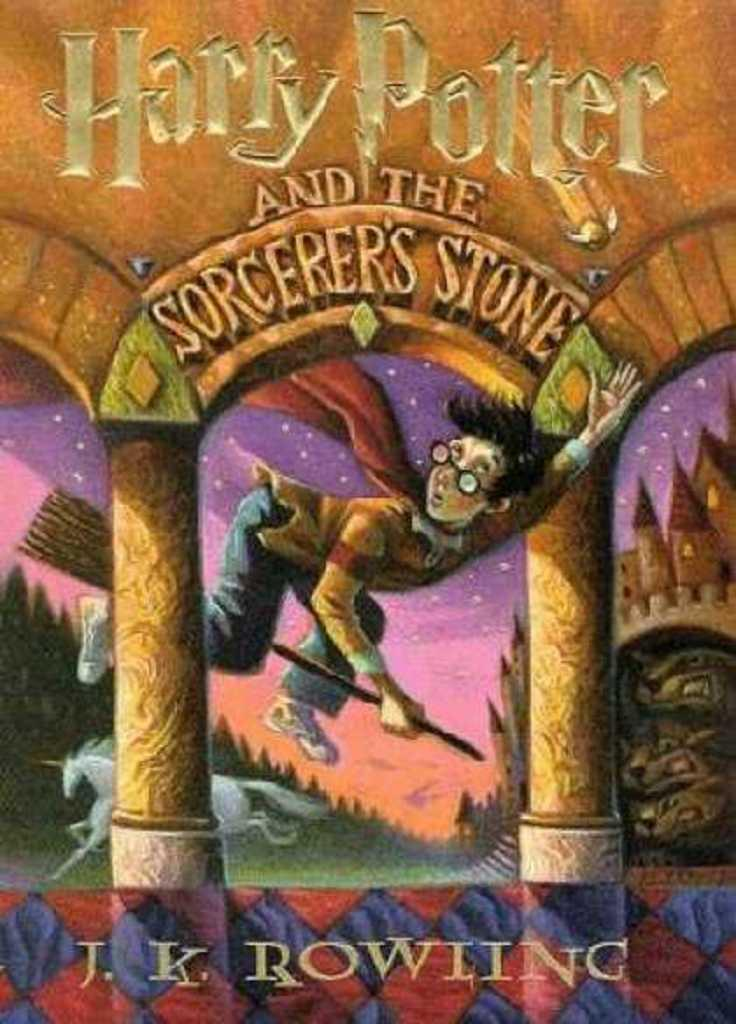Provide a one-sentence caption for the provided image. Cover of a Harry Potter book with a boy riding a broomstick on the cover. 